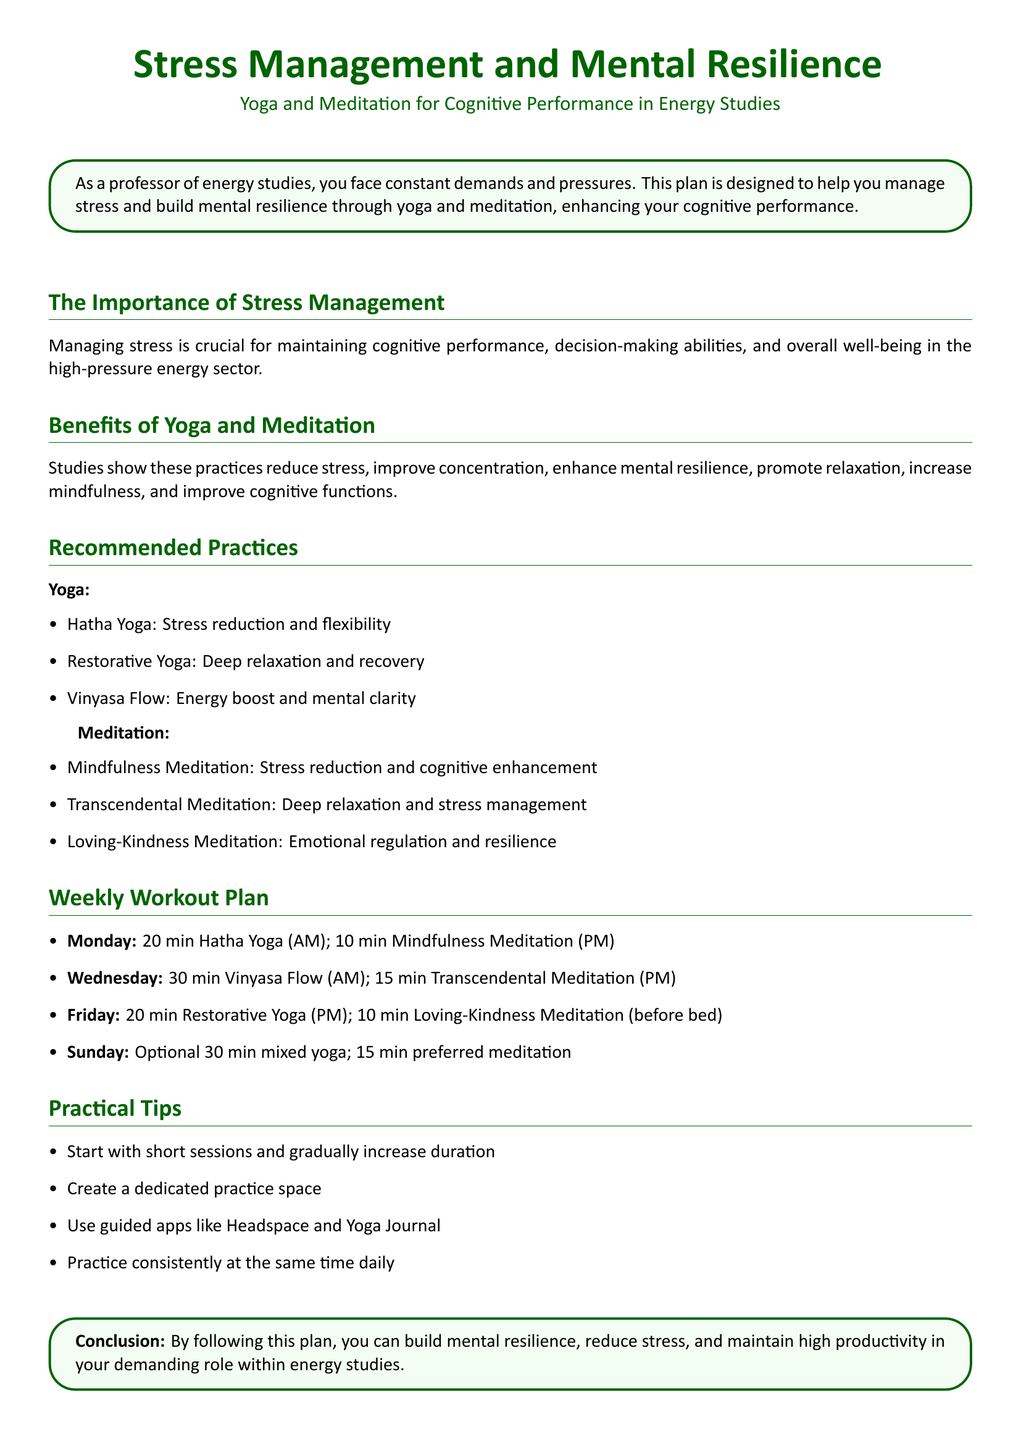What is the title of the document? The title of the document is found at the beginning and clearly states its focus.
Answer: Stress Management and Mental Resilience What practices are recommended for stress management? The document lists specific practices under yoga and meditation sections.
Answer: Yoga and Meditation How long is the recommended Hatha Yoga session? The duration is specified in the weekly workout plan section.
Answer: 20 min Which day includes Vinyasa Flow? This is indicated in the weekly workout plan detailing the activities for each day.
Answer: Wednesday What meditation type is suggested before bed? This is found in the weekly workout plan section detailing the evening routine.
Answer: Loving-Kindness Meditation What is the primary purpose of the document? The conclusion summarizes the overall goal of the workout plan.
Answer: Build mental resilience How many minutes is the optional Sunday yoga practice? The document specifies the duration for the optional practice in the weekly plan.
Answer: 30 min Which meditation type is linked with emotional regulation? This information is found under the benefits section of meditation practices.
Answer: Loving-Kindness Meditation What is advised for creating a dedicated practice space? The practical tips section advises creating a specific area for yoga and meditation practices.
Answer: Create a dedicated practice space 